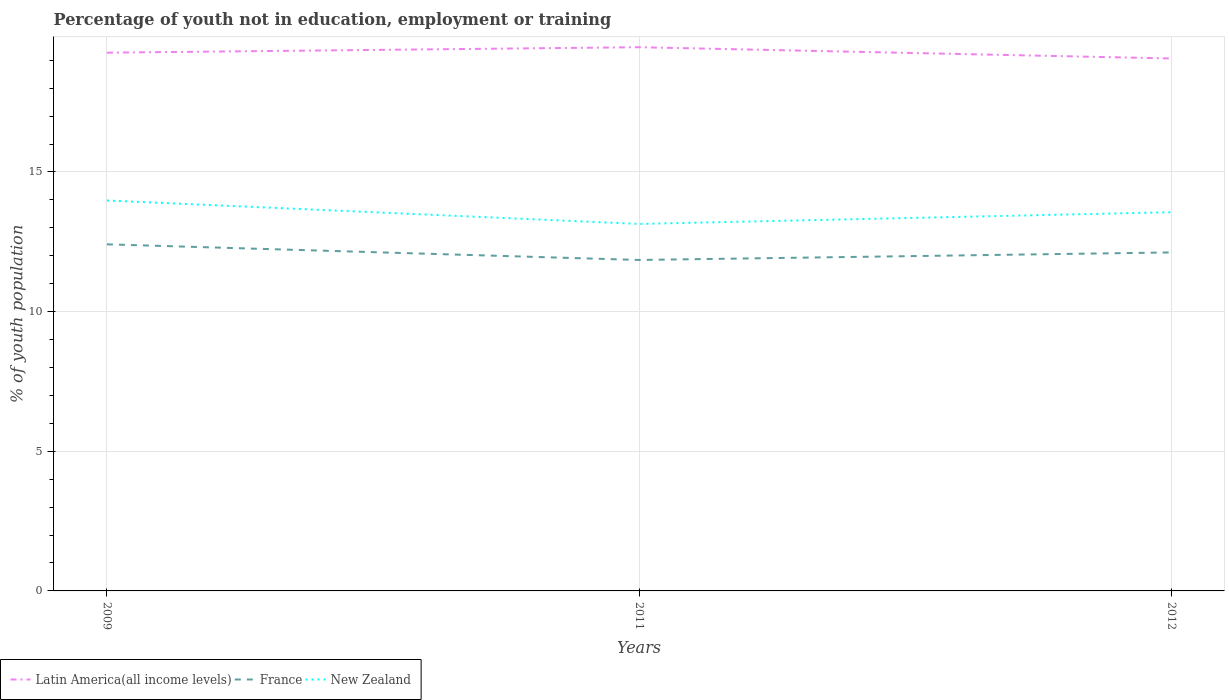Across all years, what is the maximum percentage of unemployed youth population in in Latin America(all income levels)?
Your answer should be very brief. 19.07. In which year was the percentage of unemployed youth population in in France maximum?
Your answer should be very brief. 2011. What is the total percentage of unemployed youth population in in France in the graph?
Ensure brevity in your answer.  -0.27. What is the difference between the highest and the second highest percentage of unemployed youth population in in Latin America(all income levels)?
Your answer should be very brief. 0.4. What is the difference between the highest and the lowest percentage of unemployed youth population in in France?
Your response must be concise. 1. How many lines are there?
Provide a short and direct response. 3. How many years are there in the graph?
Ensure brevity in your answer.  3. Are the values on the major ticks of Y-axis written in scientific E-notation?
Your response must be concise. No. Does the graph contain any zero values?
Ensure brevity in your answer.  No. Does the graph contain grids?
Your answer should be compact. Yes. Where does the legend appear in the graph?
Your answer should be very brief. Bottom left. How are the legend labels stacked?
Offer a very short reply. Horizontal. What is the title of the graph?
Make the answer very short. Percentage of youth not in education, employment or training. What is the label or title of the X-axis?
Your answer should be compact. Years. What is the label or title of the Y-axis?
Offer a terse response. % of youth population. What is the % of youth population in Latin America(all income levels) in 2009?
Give a very brief answer. 19.27. What is the % of youth population in France in 2009?
Keep it short and to the point. 12.41. What is the % of youth population of New Zealand in 2009?
Offer a very short reply. 13.98. What is the % of youth population in Latin America(all income levels) in 2011?
Your answer should be compact. 19.47. What is the % of youth population of France in 2011?
Provide a succinct answer. 11.85. What is the % of youth population of New Zealand in 2011?
Give a very brief answer. 13.14. What is the % of youth population in Latin America(all income levels) in 2012?
Your answer should be compact. 19.07. What is the % of youth population in France in 2012?
Give a very brief answer. 12.12. What is the % of youth population of New Zealand in 2012?
Your answer should be compact. 13.56. Across all years, what is the maximum % of youth population in Latin America(all income levels)?
Your response must be concise. 19.47. Across all years, what is the maximum % of youth population of France?
Your response must be concise. 12.41. Across all years, what is the maximum % of youth population of New Zealand?
Provide a short and direct response. 13.98. Across all years, what is the minimum % of youth population of Latin America(all income levels)?
Provide a short and direct response. 19.07. Across all years, what is the minimum % of youth population of France?
Provide a short and direct response. 11.85. Across all years, what is the minimum % of youth population of New Zealand?
Ensure brevity in your answer.  13.14. What is the total % of youth population in Latin America(all income levels) in the graph?
Keep it short and to the point. 57.81. What is the total % of youth population in France in the graph?
Keep it short and to the point. 36.38. What is the total % of youth population of New Zealand in the graph?
Your answer should be compact. 40.68. What is the difference between the % of youth population in Latin America(all income levels) in 2009 and that in 2011?
Provide a short and direct response. -0.2. What is the difference between the % of youth population of France in 2009 and that in 2011?
Offer a terse response. 0.56. What is the difference between the % of youth population in New Zealand in 2009 and that in 2011?
Your response must be concise. 0.84. What is the difference between the % of youth population in Latin America(all income levels) in 2009 and that in 2012?
Provide a short and direct response. 0.21. What is the difference between the % of youth population in France in 2009 and that in 2012?
Your answer should be compact. 0.29. What is the difference between the % of youth population of New Zealand in 2009 and that in 2012?
Your response must be concise. 0.42. What is the difference between the % of youth population in Latin America(all income levels) in 2011 and that in 2012?
Make the answer very short. 0.4. What is the difference between the % of youth population of France in 2011 and that in 2012?
Your response must be concise. -0.27. What is the difference between the % of youth population in New Zealand in 2011 and that in 2012?
Ensure brevity in your answer.  -0.42. What is the difference between the % of youth population in Latin America(all income levels) in 2009 and the % of youth population in France in 2011?
Offer a very short reply. 7.42. What is the difference between the % of youth population of Latin America(all income levels) in 2009 and the % of youth population of New Zealand in 2011?
Your answer should be compact. 6.13. What is the difference between the % of youth population in France in 2009 and the % of youth population in New Zealand in 2011?
Offer a terse response. -0.73. What is the difference between the % of youth population of Latin America(all income levels) in 2009 and the % of youth population of France in 2012?
Ensure brevity in your answer.  7.15. What is the difference between the % of youth population of Latin America(all income levels) in 2009 and the % of youth population of New Zealand in 2012?
Keep it short and to the point. 5.71. What is the difference between the % of youth population of France in 2009 and the % of youth population of New Zealand in 2012?
Your response must be concise. -1.15. What is the difference between the % of youth population in Latin America(all income levels) in 2011 and the % of youth population in France in 2012?
Make the answer very short. 7.35. What is the difference between the % of youth population of Latin America(all income levels) in 2011 and the % of youth population of New Zealand in 2012?
Keep it short and to the point. 5.91. What is the difference between the % of youth population of France in 2011 and the % of youth population of New Zealand in 2012?
Offer a terse response. -1.71. What is the average % of youth population of Latin America(all income levels) per year?
Provide a succinct answer. 19.27. What is the average % of youth population in France per year?
Your response must be concise. 12.13. What is the average % of youth population in New Zealand per year?
Offer a terse response. 13.56. In the year 2009, what is the difference between the % of youth population in Latin America(all income levels) and % of youth population in France?
Offer a terse response. 6.86. In the year 2009, what is the difference between the % of youth population of Latin America(all income levels) and % of youth population of New Zealand?
Your answer should be very brief. 5.29. In the year 2009, what is the difference between the % of youth population of France and % of youth population of New Zealand?
Keep it short and to the point. -1.57. In the year 2011, what is the difference between the % of youth population of Latin America(all income levels) and % of youth population of France?
Provide a short and direct response. 7.62. In the year 2011, what is the difference between the % of youth population of Latin America(all income levels) and % of youth population of New Zealand?
Offer a terse response. 6.33. In the year 2011, what is the difference between the % of youth population of France and % of youth population of New Zealand?
Keep it short and to the point. -1.29. In the year 2012, what is the difference between the % of youth population of Latin America(all income levels) and % of youth population of France?
Your response must be concise. 6.95. In the year 2012, what is the difference between the % of youth population in Latin America(all income levels) and % of youth population in New Zealand?
Your answer should be compact. 5.5. In the year 2012, what is the difference between the % of youth population in France and % of youth population in New Zealand?
Offer a very short reply. -1.44. What is the ratio of the % of youth population of France in 2009 to that in 2011?
Keep it short and to the point. 1.05. What is the ratio of the % of youth population of New Zealand in 2009 to that in 2011?
Provide a short and direct response. 1.06. What is the ratio of the % of youth population in Latin America(all income levels) in 2009 to that in 2012?
Keep it short and to the point. 1.01. What is the ratio of the % of youth population of France in 2009 to that in 2012?
Ensure brevity in your answer.  1.02. What is the ratio of the % of youth population in New Zealand in 2009 to that in 2012?
Your response must be concise. 1.03. What is the ratio of the % of youth population in Latin America(all income levels) in 2011 to that in 2012?
Offer a terse response. 1.02. What is the ratio of the % of youth population of France in 2011 to that in 2012?
Make the answer very short. 0.98. What is the difference between the highest and the second highest % of youth population in Latin America(all income levels)?
Keep it short and to the point. 0.2. What is the difference between the highest and the second highest % of youth population in France?
Your answer should be compact. 0.29. What is the difference between the highest and the second highest % of youth population in New Zealand?
Keep it short and to the point. 0.42. What is the difference between the highest and the lowest % of youth population in Latin America(all income levels)?
Give a very brief answer. 0.4. What is the difference between the highest and the lowest % of youth population in France?
Offer a very short reply. 0.56. What is the difference between the highest and the lowest % of youth population in New Zealand?
Provide a succinct answer. 0.84. 